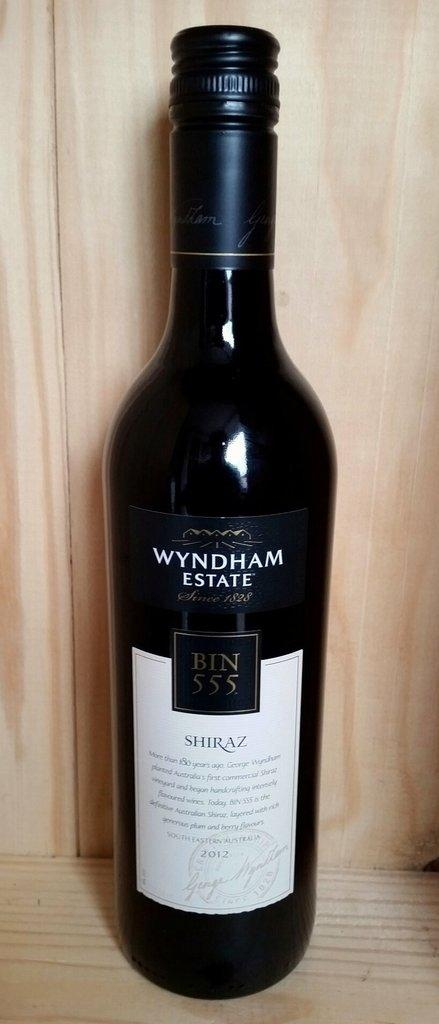Provide a one-sentence caption for the provided image. A bottle of Wyndham Estate shiraz has a screw top. 